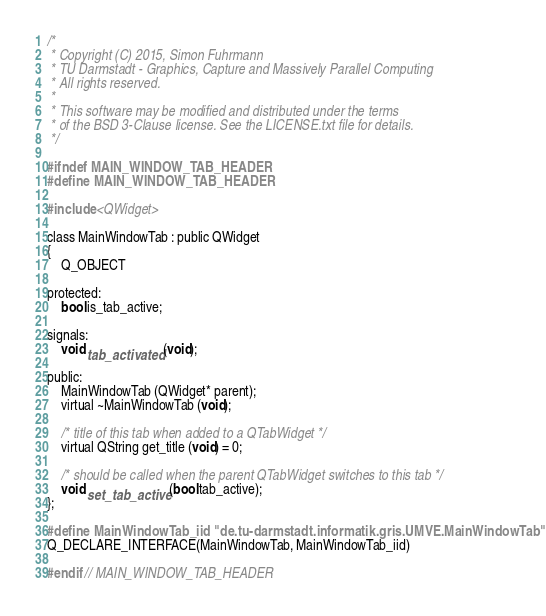<code> <loc_0><loc_0><loc_500><loc_500><_C_>/*
 * Copyright (C) 2015, Simon Fuhrmann
 * TU Darmstadt - Graphics, Capture and Massively Parallel Computing
 * All rights reserved.
 *
 * This software may be modified and distributed under the terms
 * of the BSD 3-Clause license. See the LICENSE.txt file for details.
 */

#ifndef MAIN_WINDOW_TAB_HEADER
#define MAIN_WINDOW_TAB_HEADER

#include <QWidget>

class MainWindowTab : public QWidget
{
    Q_OBJECT

protected:
    bool is_tab_active;

signals:
    void tab_activated (void);

public:
    MainWindowTab (QWidget* parent);
    virtual ~MainWindowTab (void);

    /* title of this tab when added to a QTabWidget */
    virtual QString get_title (void) = 0;

    /* should be called when the parent QTabWidget switches to this tab */
    void set_tab_active (bool tab_active);
};

#define MainWindowTab_iid "de.tu-darmstadt.informatik.gris.UMVE.MainWindowTab"
Q_DECLARE_INTERFACE(MainWindowTab, MainWindowTab_iid)

#endif // MAIN_WINDOW_TAB_HEADER
</code> 